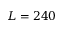Convert formula to latex. <formula><loc_0><loc_0><loc_500><loc_500>L = 2 4 0</formula> 